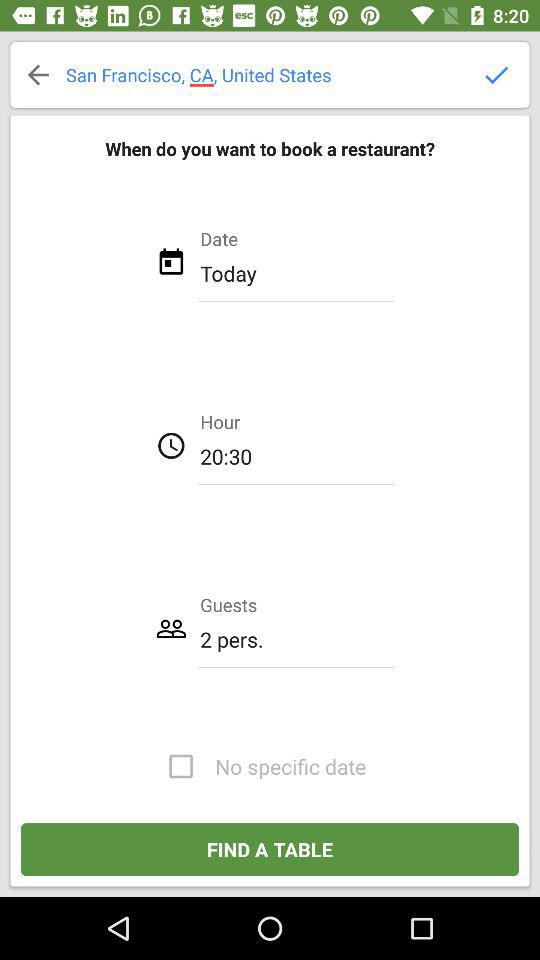What is the status of "No specific date"? The status is "off". 